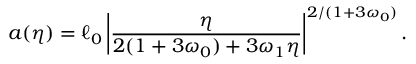Convert formula to latex. <formula><loc_0><loc_0><loc_500><loc_500>a ( \eta ) = \ell _ { 0 } \left | \frac { \eta } { 2 ( 1 + 3 \omega _ { 0 } ) + 3 \omega _ { 1 } \eta } \right | ^ { 2 / ( 1 + 3 \omega _ { 0 } ) } .</formula> 